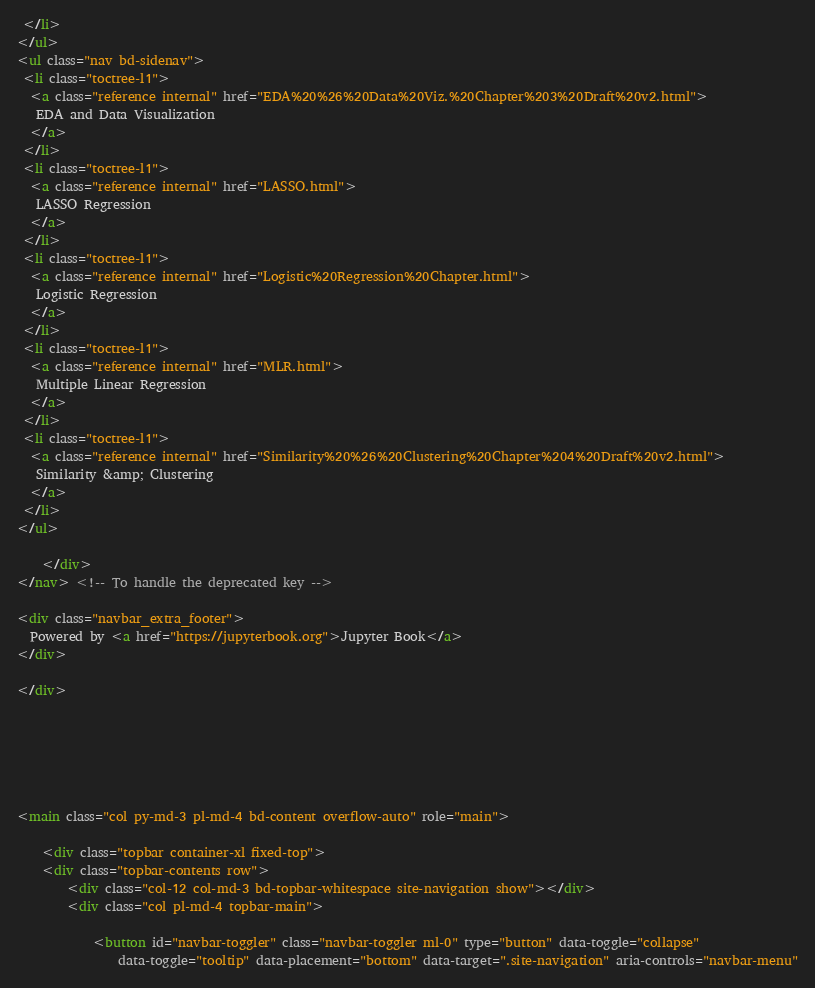Convert code to text. <code><loc_0><loc_0><loc_500><loc_500><_HTML_> </li>
</ul>
<ul class="nav bd-sidenav">
 <li class="toctree-l1">
  <a class="reference internal" href="EDA%20%26%20Data%20Viz.%20Chapter%203%20Draft%20v2.html">
   EDA and Data Visualization
  </a>
 </li>
 <li class="toctree-l1">
  <a class="reference internal" href="LASSO.html">
   LASSO Regression
  </a>
 </li>
 <li class="toctree-l1">
  <a class="reference internal" href="Logistic%20Regression%20Chapter.html">
   Logistic Regression
  </a>
 </li>
 <li class="toctree-l1">
  <a class="reference internal" href="MLR.html">
   Multiple Linear Regression
  </a>
 </li>
 <li class="toctree-l1">
  <a class="reference internal" href="Similarity%20%26%20Clustering%20Chapter%204%20Draft%20v2.html">
   Similarity &amp; Clustering
  </a>
 </li>
</ul>

    </div>
</nav> <!-- To handle the deprecated key -->

<div class="navbar_extra_footer">
  Powered by <a href="https://jupyterbook.org">Jupyter Book</a>
</div>

</div>


          


          
<main class="col py-md-3 pl-md-4 bd-content overflow-auto" role="main">
    
    <div class="topbar container-xl fixed-top">
    <div class="topbar-contents row">
        <div class="col-12 col-md-3 bd-topbar-whitespace site-navigation show"></div>
        <div class="col pl-md-4 topbar-main">
            
            <button id="navbar-toggler" class="navbar-toggler ml-0" type="button" data-toggle="collapse"
                data-toggle="tooltip" data-placement="bottom" data-target=".site-navigation" aria-controls="navbar-menu"</code> 